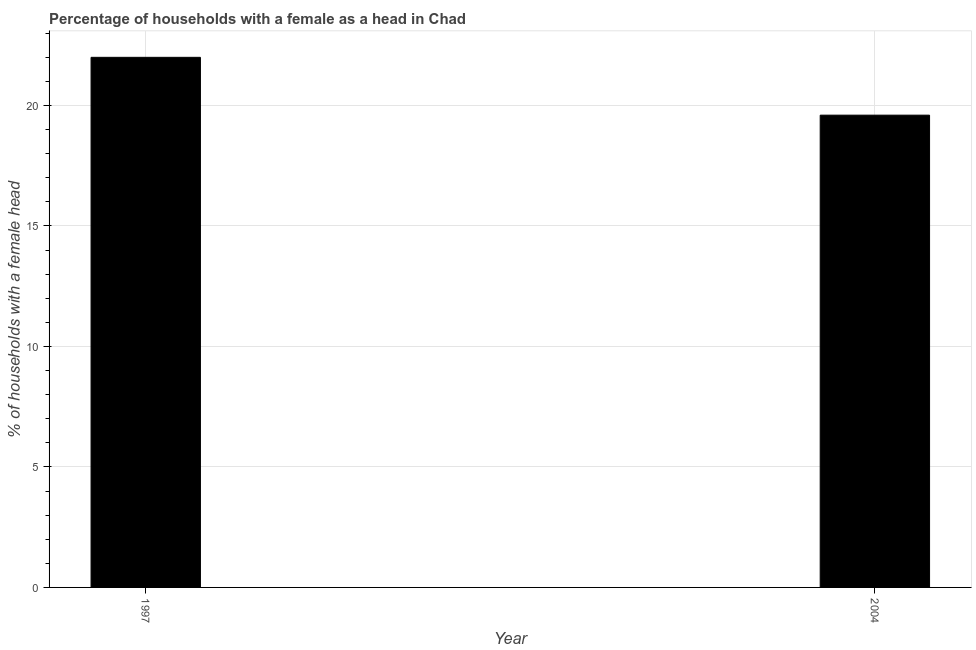What is the title of the graph?
Offer a terse response. Percentage of households with a female as a head in Chad. What is the label or title of the X-axis?
Provide a short and direct response. Year. What is the label or title of the Y-axis?
Ensure brevity in your answer.  % of households with a female head. What is the number of female supervised households in 2004?
Provide a succinct answer. 19.6. Across all years, what is the minimum number of female supervised households?
Offer a terse response. 19.6. What is the sum of the number of female supervised households?
Offer a very short reply. 41.6. What is the difference between the number of female supervised households in 1997 and 2004?
Your answer should be compact. 2.4. What is the average number of female supervised households per year?
Provide a short and direct response. 20.8. What is the median number of female supervised households?
Ensure brevity in your answer.  20.8. What is the ratio of the number of female supervised households in 1997 to that in 2004?
Your answer should be compact. 1.12. How many bars are there?
Keep it short and to the point. 2. Are all the bars in the graph horizontal?
Your answer should be very brief. No. How many years are there in the graph?
Give a very brief answer. 2. What is the difference between two consecutive major ticks on the Y-axis?
Offer a very short reply. 5. What is the % of households with a female head in 2004?
Your answer should be compact. 19.6. What is the difference between the % of households with a female head in 1997 and 2004?
Give a very brief answer. 2.4. What is the ratio of the % of households with a female head in 1997 to that in 2004?
Your response must be concise. 1.12. 